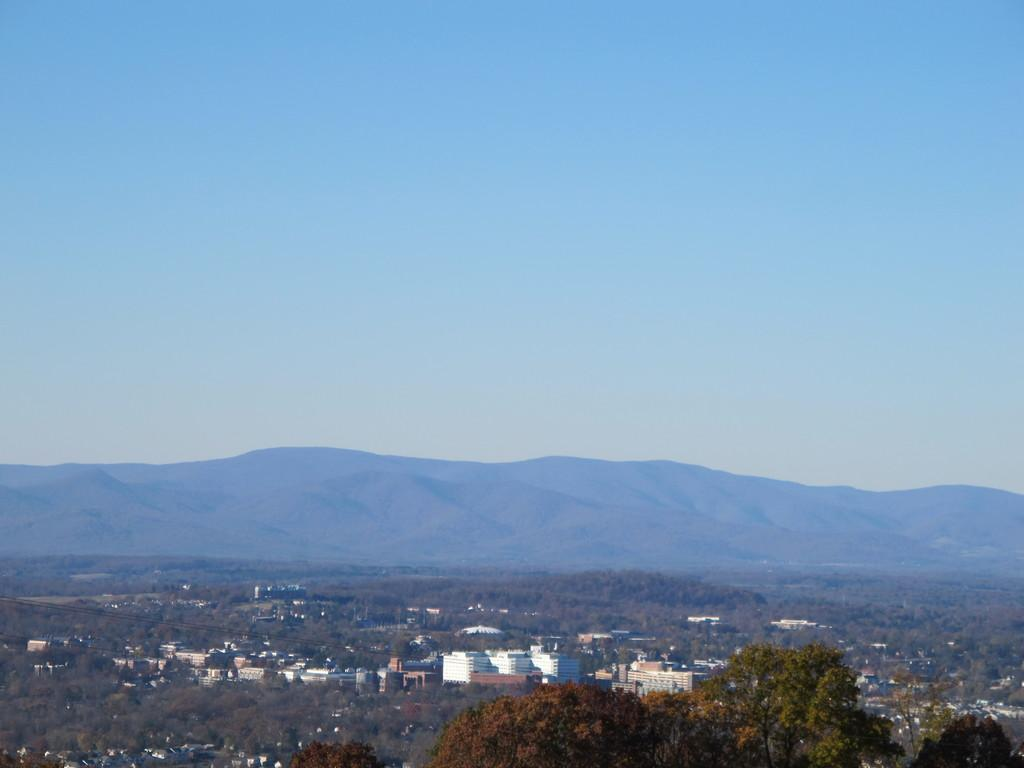What type of vegetation can be seen in the image? There are trees in the image. What type of structures are visible in the image? There are houses in the image. What can be seen in the distance in the image? There is a mountain in the background of the image. What is visible above the houses and trees in the image? The sky is visible in the background of the image. How many leaves can be seen on the horse in the image? There is no horse present in the image, so it is not possible to determine the number of leaves on a horse. 